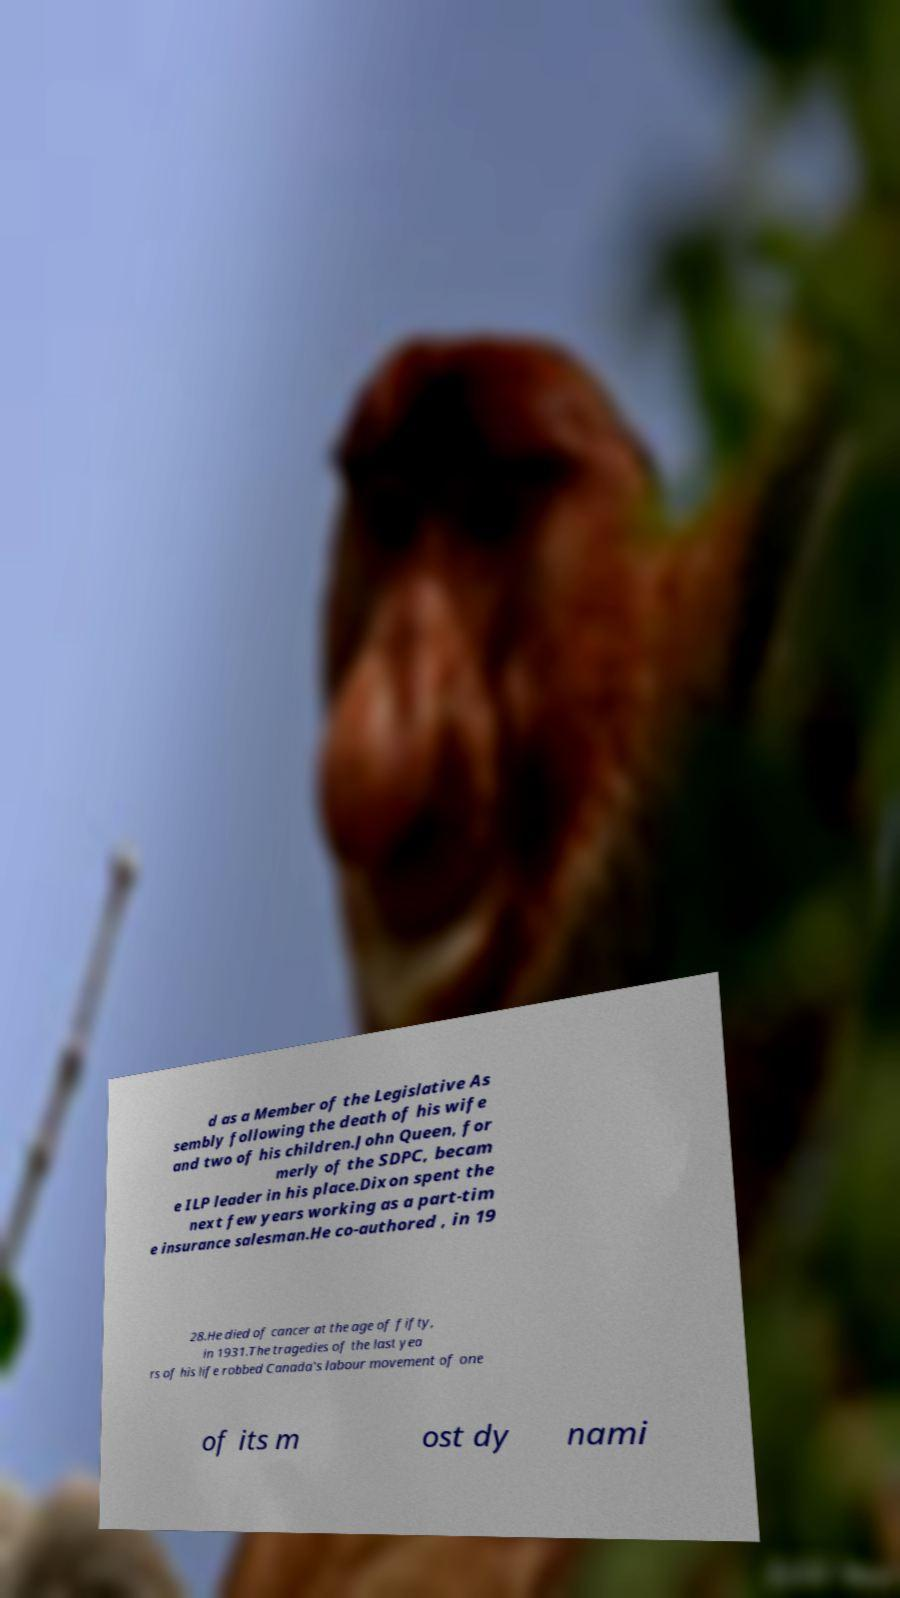What messages or text are displayed in this image? I need them in a readable, typed format. d as a Member of the Legislative As sembly following the death of his wife and two of his children.John Queen, for merly of the SDPC, becam e ILP leader in his place.Dixon spent the next few years working as a part-tim e insurance salesman.He co-authored , in 19 28.He died of cancer at the age of fifty, in 1931.The tragedies of the last yea rs of his life robbed Canada's labour movement of one of its m ost dy nami 